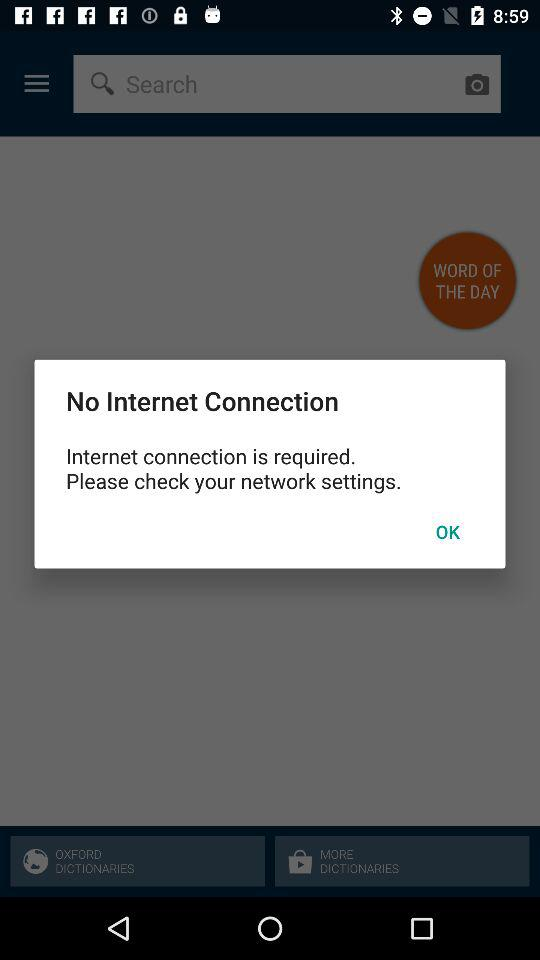Is there an internet connection? There is no internet connection. 